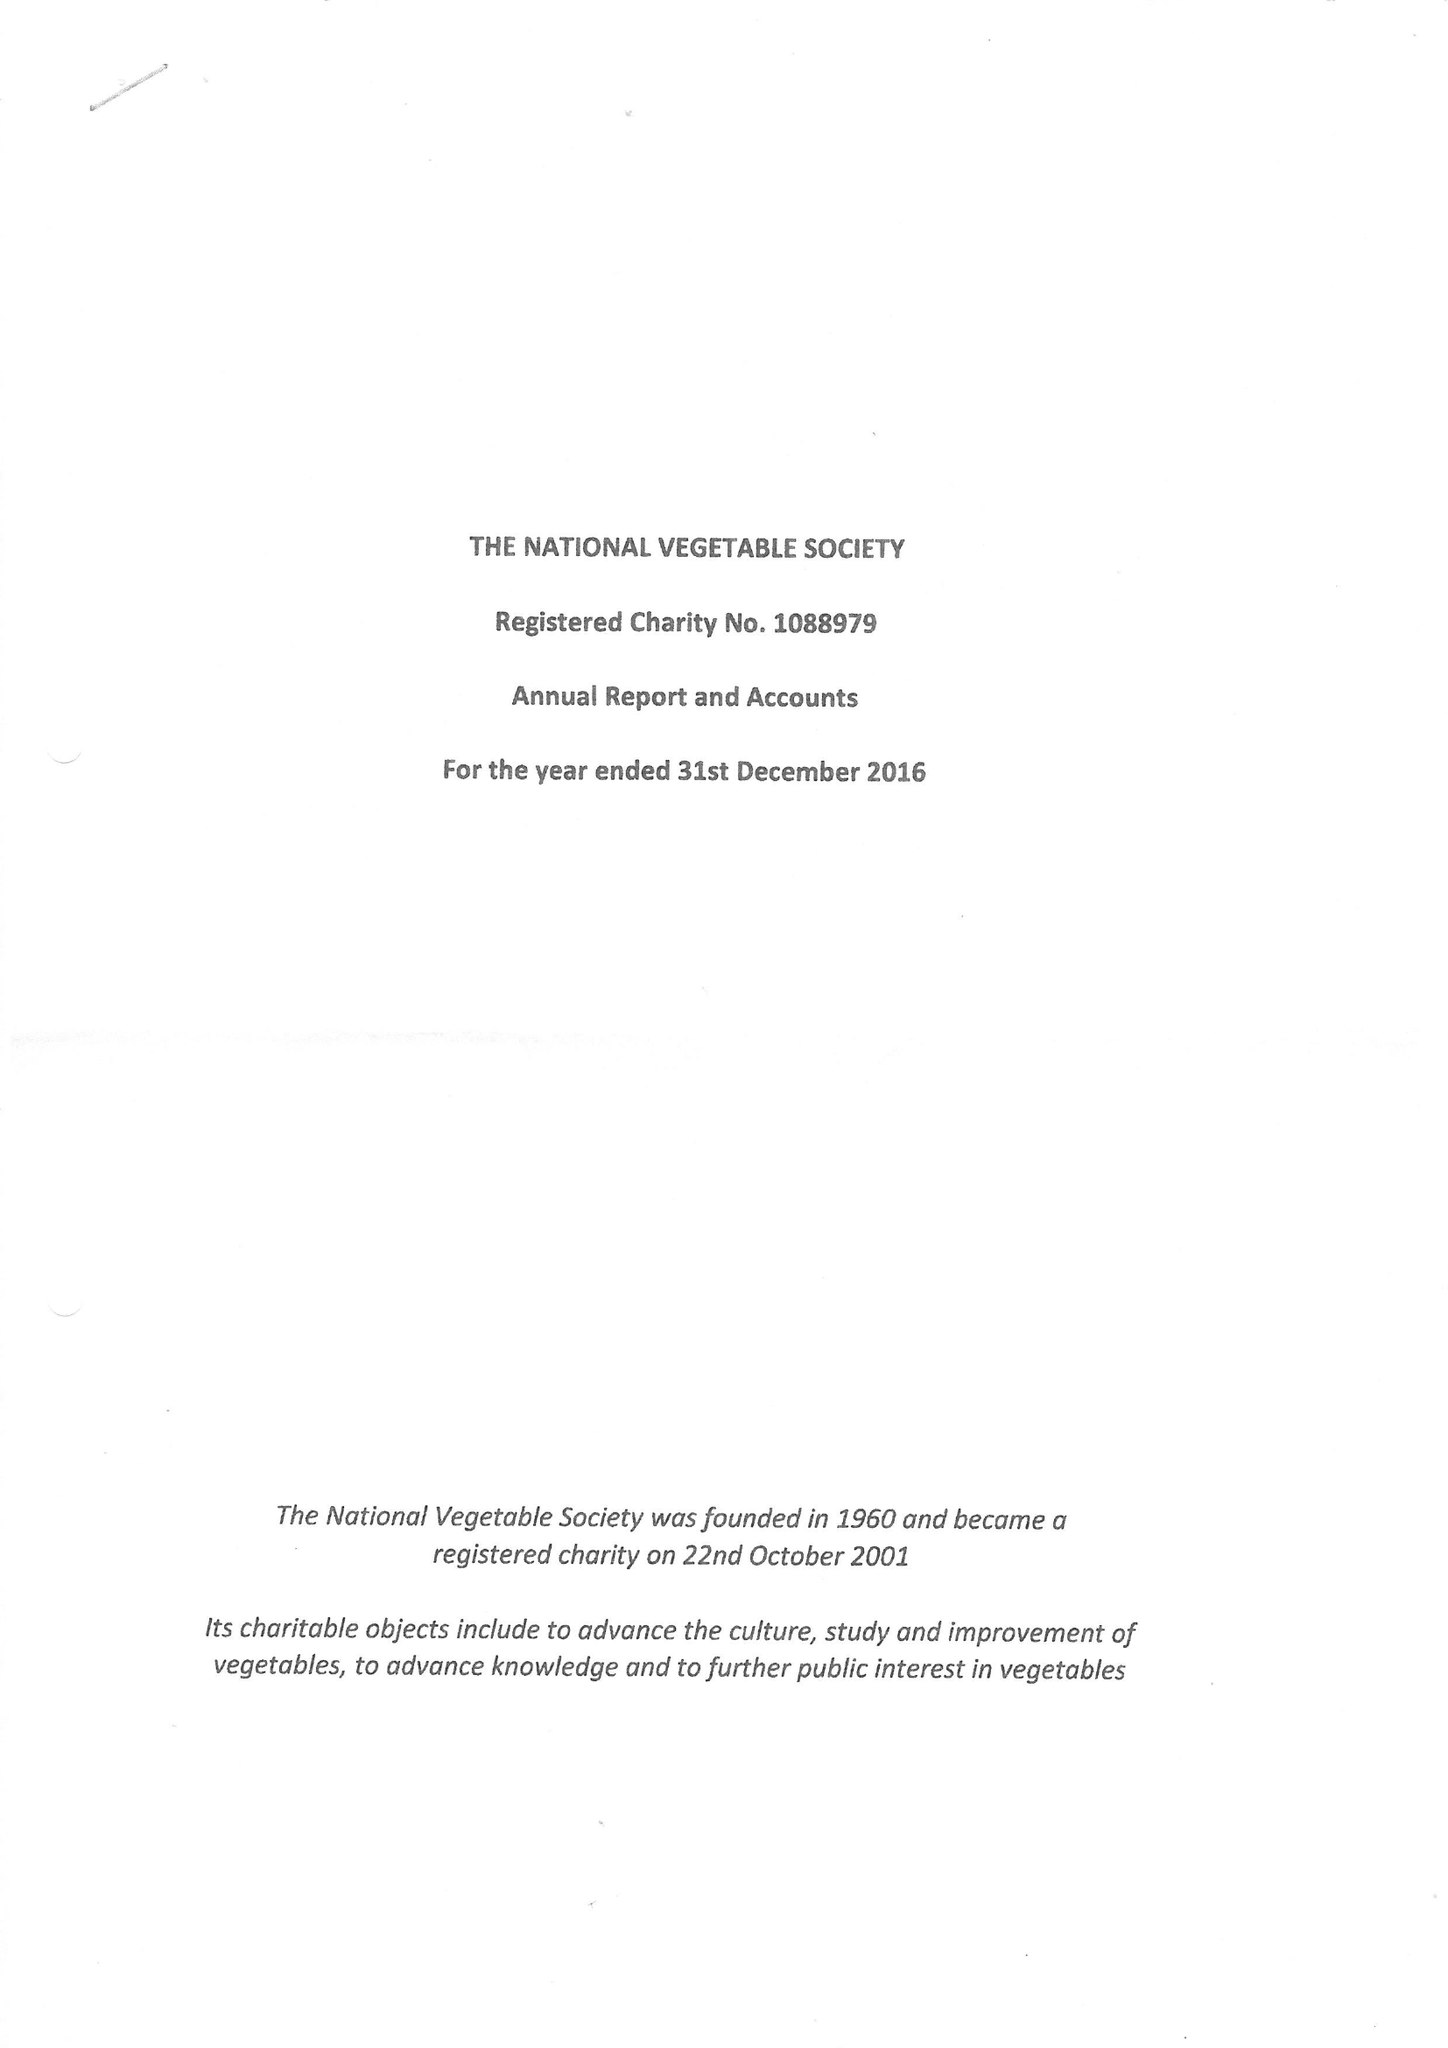What is the value for the address__street_line?
Answer the question using a single word or phrase. 4 CANMORE STREET 